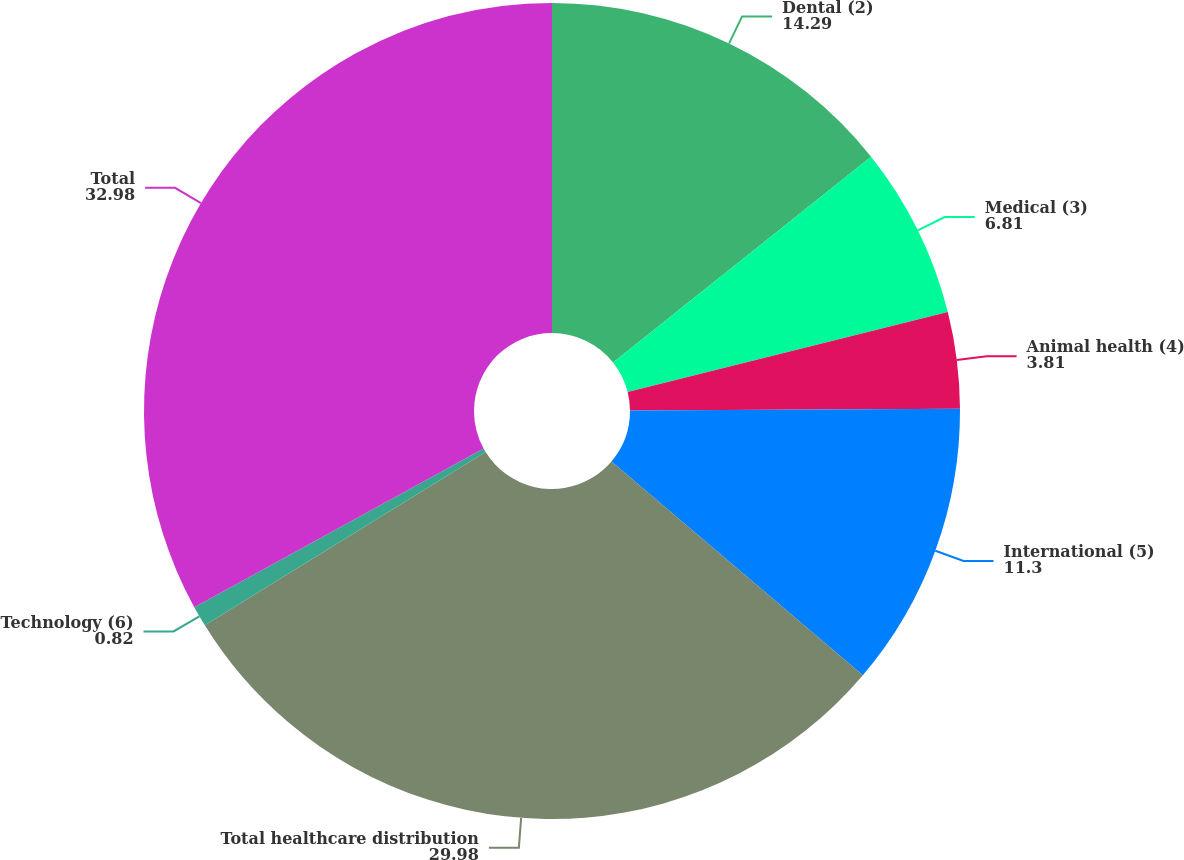Convert chart to OTSL. <chart><loc_0><loc_0><loc_500><loc_500><pie_chart><fcel>Dental (2)<fcel>Medical (3)<fcel>Animal health (4)<fcel>International (5)<fcel>Total healthcare distribution<fcel>Technology (6)<fcel>Total<nl><fcel>14.29%<fcel>6.81%<fcel>3.81%<fcel>11.3%<fcel>29.98%<fcel>0.82%<fcel>32.98%<nl></chart> 